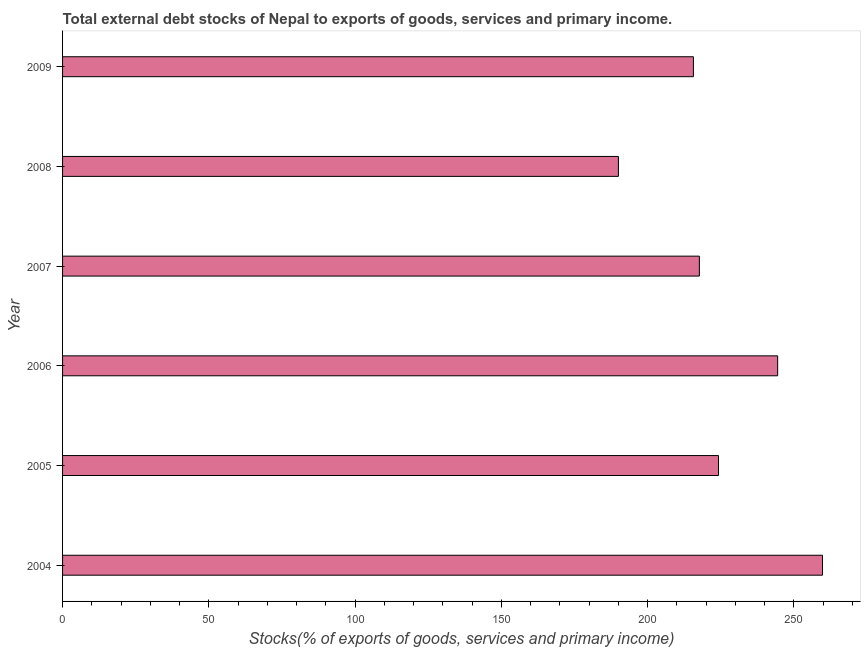What is the title of the graph?
Ensure brevity in your answer.  Total external debt stocks of Nepal to exports of goods, services and primary income. What is the label or title of the X-axis?
Make the answer very short. Stocks(% of exports of goods, services and primary income). What is the label or title of the Y-axis?
Make the answer very short. Year. What is the external debt stocks in 2006?
Your answer should be compact. 244.46. Across all years, what is the maximum external debt stocks?
Provide a short and direct response. 259.79. Across all years, what is the minimum external debt stocks?
Your answer should be very brief. 190.02. In which year was the external debt stocks maximum?
Provide a short and direct response. 2004. What is the sum of the external debt stocks?
Offer a terse response. 1351.87. What is the difference between the external debt stocks in 2006 and 2007?
Provide a short and direct response. 26.76. What is the average external debt stocks per year?
Offer a very short reply. 225.31. What is the median external debt stocks?
Make the answer very short. 220.97. Do a majority of the years between 2004 and 2005 (inclusive) have external debt stocks greater than 90 %?
Ensure brevity in your answer.  Yes. What is the ratio of the external debt stocks in 2006 to that in 2008?
Give a very brief answer. 1.29. What is the difference between the highest and the second highest external debt stocks?
Provide a succinct answer. 15.33. What is the difference between the highest and the lowest external debt stocks?
Make the answer very short. 69.77. In how many years, is the external debt stocks greater than the average external debt stocks taken over all years?
Offer a very short reply. 2. How many years are there in the graph?
Offer a very short reply. 6. What is the Stocks(% of exports of goods, services and primary income) in 2004?
Give a very brief answer. 259.79. What is the Stocks(% of exports of goods, services and primary income) in 2005?
Make the answer very short. 224.24. What is the Stocks(% of exports of goods, services and primary income) in 2006?
Provide a succinct answer. 244.46. What is the Stocks(% of exports of goods, services and primary income) of 2007?
Keep it short and to the point. 217.7. What is the Stocks(% of exports of goods, services and primary income) of 2008?
Make the answer very short. 190.02. What is the Stocks(% of exports of goods, services and primary income) of 2009?
Your answer should be compact. 215.66. What is the difference between the Stocks(% of exports of goods, services and primary income) in 2004 and 2005?
Your response must be concise. 35.55. What is the difference between the Stocks(% of exports of goods, services and primary income) in 2004 and 2006?
Provide a short and direct response. 15.33. What is the difference between the Stocks(% of exports of goods, services and primary income) in 2004 and 2007?
Offer a terse response. 42.09. What is the difference between the Stocks(% of exports of goods, services and primary income) in 2004 and 2008?
Offer a very short reply. 69.77. What is the difference between the Stocks(% of exports of goods, services and primary income) in 2004 and 2009?
Your answer should be compact. 44.13. What is the difference between the Stocks(% of exports of goods, services and primary income) in 2005 and 2006?
Offer a terse response. -20.22. What is the difference between the Stocks(% of exports of goods, services and primary income) in 2005 and 2007?
Your response must be concise. 6.54. What is the difference between the Stocks(% of exports of goods, services and primary income) in 2005 and 2008?
Your answer should be compact. 34.21. What is the difference between the Stocks(% of exports of goods, services and primary income) in 2005 and 2009?
Ensure brevity in your answer.  8.58. What is the difference between the Stocks(% of exports of goods, services and primary income) in 2006 and 2007?
Offer a very short reply. 26.76. What is the difference between the Stocks(% of exports of goods, services and primary income) in 2006 and 2008?
Give a very brief answer. 54.43. What is the difference between the Stocks(% of exports of goods, services and primary income) in 2006 and 2009?
Your answer should be compact. 28.8. What is the difference between the Stocks(% of exports of goods, services and primary income) in 2007 and 2008?
Ensure brevity in your answer.  27.68. What is the difference between the Stocks(% of exports of goods, services and primary income) in 2007 and 2009?
Make the answer very short. 2.04. What is the difference between the Stocks(% of exports of goods, services and primary income) in 2008 and 2009?
Give a very brief answer. -25.64. What is the ratio of the Stocks(% of exports of goods, services and primary income) in 2004 to that in 2005?
Give a very brief answer. 1.16. What is the ratio of the Stocks(% of exports of goods, services and primary income) in 2004 to that in 2006?
Your answer should be compact. 1.06. What is the ratio of the Stocks(% of exports of goods, services and primary income) in 2004 to that in 2007?
Provide a succinct answer. 1.19. What is the ratio of the Stocks(% of exports of goods, services and primary income) in 2004 to that in 2008?
Make the answer very short. 1.37. What is the ratio of the Stocks(% of exports of goods, services and primary income) in 2004 to that in 2009?
Keep it short and to the point. 1.21. What is the ratio of the Stocks(% of exports of goods, services and primary income) in 2005 to that in 2006?
Keep it short and to the point. 0.92. What is the ratio of the Stocks(% of exports of goods, services and primary income) in 2005 to that in 2007?
Make the answer very short. 1.03. What is the ratio of the Stocks(% of exports of goods, services and primary income) in 2005 to that in 2008?
Make the answer very short. 1.18. What is the ratio of the Stocks(% of exports of goods, services and primary income) in 2005 to that in 2009?
Offer a terse response. 1.04. What is the ratio of the Stocks(% of exports of goods, services and primary income) in 2006 to that in 2007?
Give a very brief answer. 1.12. What is the ratio of the Stocks(% of exports of goods, services and primary income) in 2006 to that in 2008?
Offer a terse response. 1.29. What is the ratio of the Stocks(% of exports of goods, services and primary income) in 2006 to that in 2009?
Provide a short and direct response. 1.13. What is the ratio of the Stocks(% of exports of goods, services and primary income) in 2007 to that in 2008?
Your response must be concise. 1.15. What is the ratio of the Stocks(% of exports of goods, services and primary income) in 2007 to that in 2009?
Keep it short and to the point. 1.01. What is the ratio of the Stocks(% of exports of goods, services and primary income) in 2008 to that in 2009?
Provide a succinct answer. 0.88. 